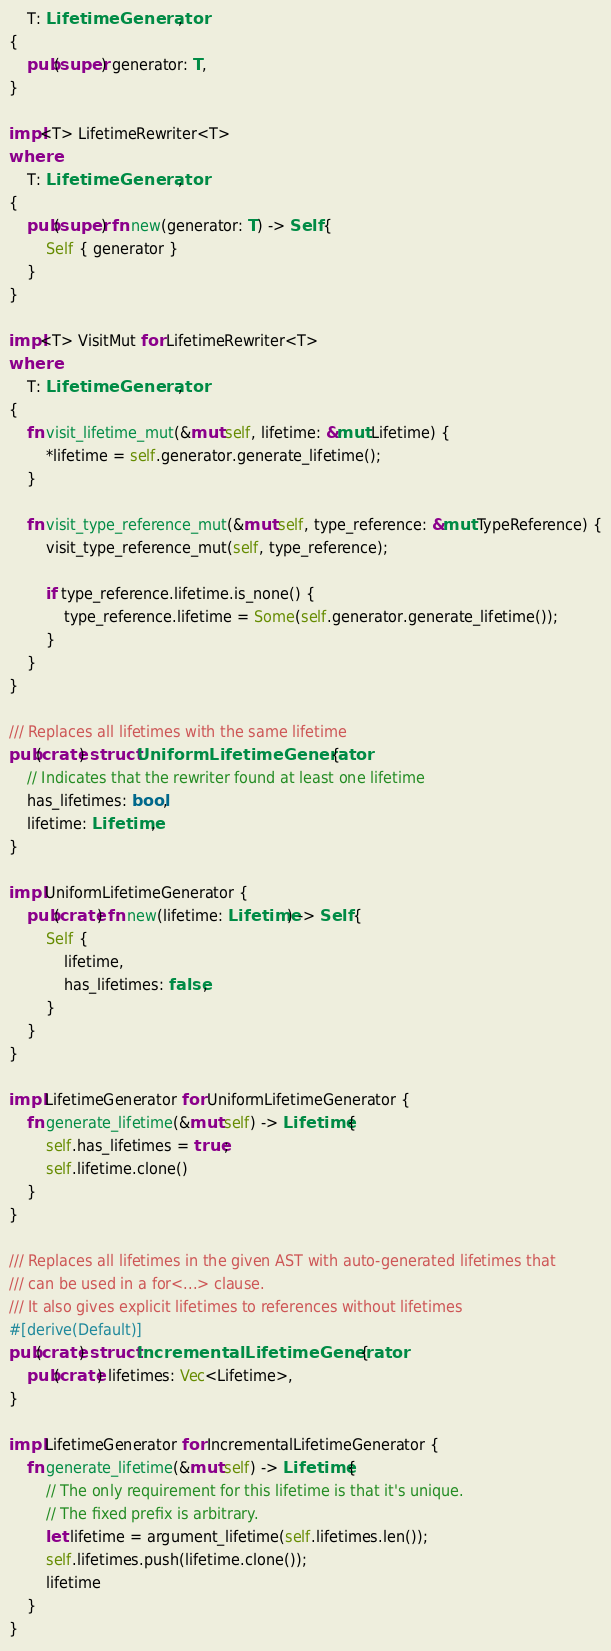Convert code to text. <code><loc_0><loc_0><loc_500><loc_500><_Rust_>    T: LifetimeGenerator,
{
    pub(super) generator: T,
}

impl<T> LifetimeRewriter<T>
where
    T: LifetimeGenerator,
{
    pub(super) fn new(generator: T) -> Self {
        Self { generator }
    }
}

impl<T> VisitMut for LifetimeRewriter<T>
where
    T: LifetimeGenerator,
{
    fn visit_lifetime_mut(&mut self, lifetime: &mut Lifetime) {
        *lifetime = self.generator.generate_lifetime();
    }

    fn visit_type_reference_mut(&mut self, type_reference: &mut TypeReference) {
        visit_type_reference_mut(self, type_reference);

        if type_reference.lifetime.is_none() {
            type_reference.lifetime = Some(self.generator.generate_lifetime());
        }
    }
}

/// Replaces all lifetimes with the same lifetime
pub(crate) struct UniformLifetimeGenerator {
    // Indicates that the rewriter found at least one lifetime
    has_lifetimes: bool,
    lifetime: Lifetime,
}

impl UniformLifetimeGenerator {
    pub(crate) fn new(lifetime: Lifetime) -> Self {
        Self {
            lifetime,
            has_lifetimes: false,
        }
    }
}

impl LifetimeGenerator for UniformLifetimeGenerator {
    fn generate_lifetime(&mut self) -> Lifetime {
        self.has_lifetimes = true;
        self.lifetime.clone()
    }
}

/// Replaces all lifetimes in the given AST with auto-generated lifetimes that
/// can be used in a for<...> clause.
/// It also gives explicit lifetimes to references without lifetimes
#[derive(Default)]
pub(crate) struct IncrementalLifetimeGenerator {
    pub(crate) lifetimes: Vec<Lifetime>,
}

impl LifetimeGenerator for IncrementalLifetimeGenerator {
    fn generate_lifetime(&mut self) -> Lifetime {
        // The only requirement for this lifetime is that it's unique.
        // The fixed prefix is arbitrary.
        let lifetime = argument_lifetime(self.lifetimes.len());
        self.lifetimes.push(lifetime.clone());
        lifetime
    }
}
</code> 